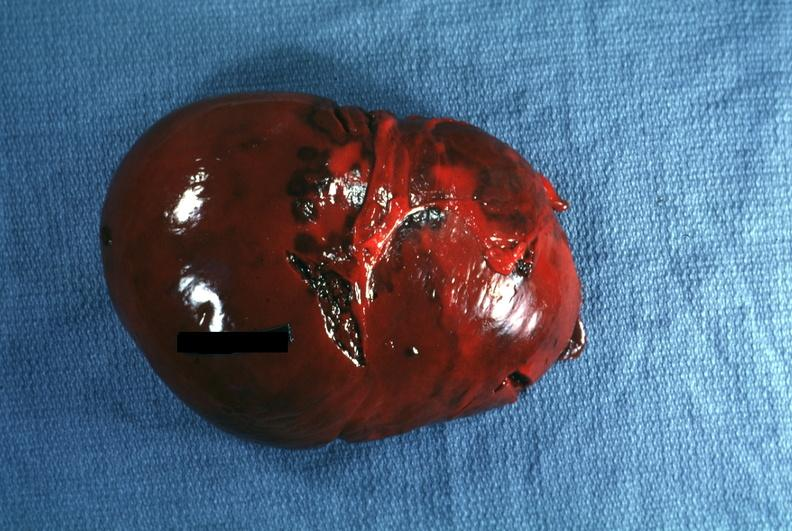what is present?
Answer the question using a single word or phrase. Traumatic rupture 